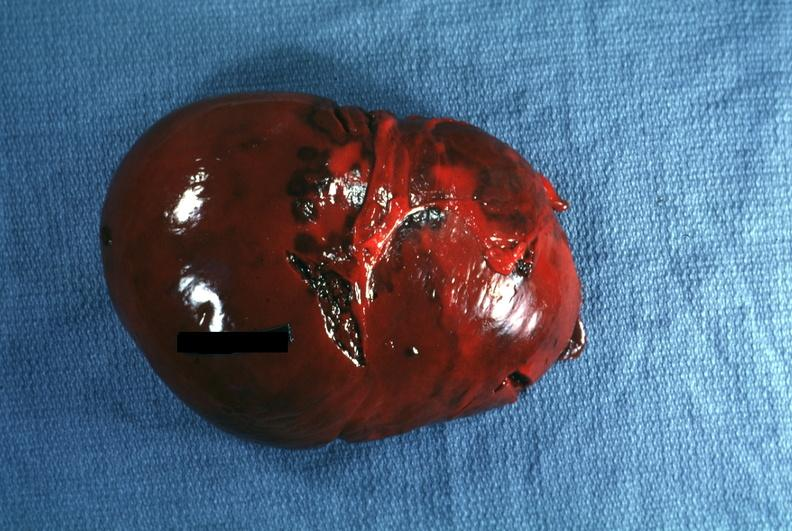what is present?
Answer the question using a single word or phrase. Traumatic rupture 